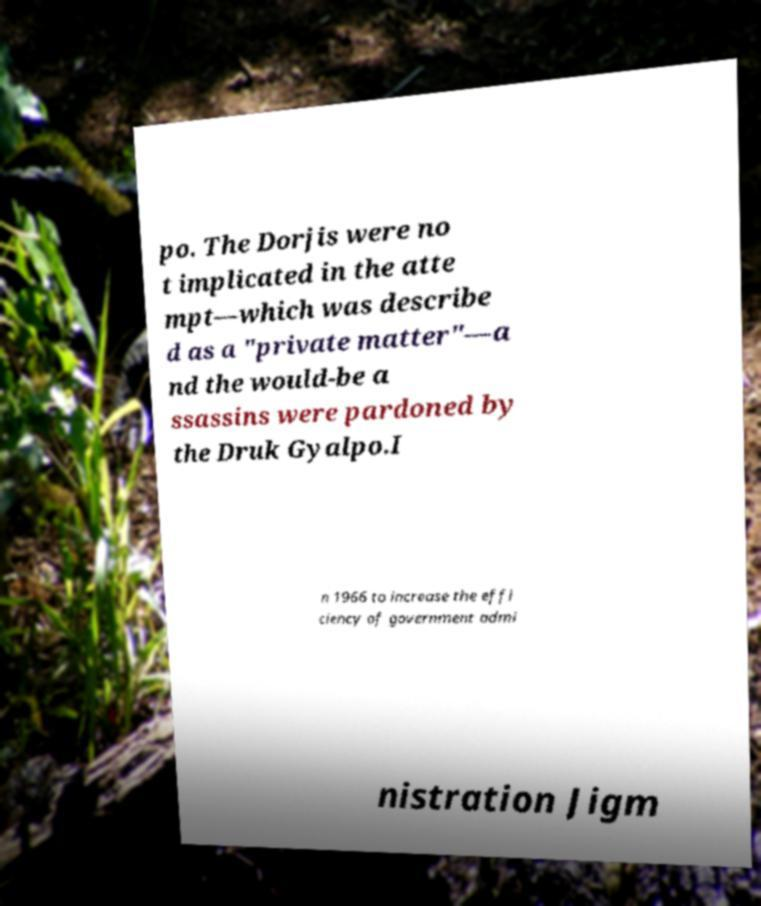Can you accurately transcribe the text from the provided image for me? po. The Dorjis were no t implicated in the atte mpt—which was describe d as a "private matter"—a nd the would-be a ssassins were pardoned by the Druk Gyalpo.I n 1966 to increase the effi ciency of government admi nistration Jigm 